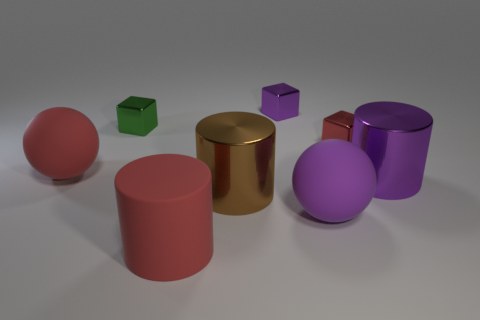Add 2 purple matte balls. How many objects exist? 10 Subtract all balls. How many objects are left? 6 Add 2 big cylinders. How many big cylinders are left? 5 Add 4 small green shiny things. How many small green shiny things exist? 5 Subtract 0 yellow cylinders. How many objects are left? 8 Subtract all red shiny blocks. Subtract all red rubber cylinders. How many objects are left? 6 